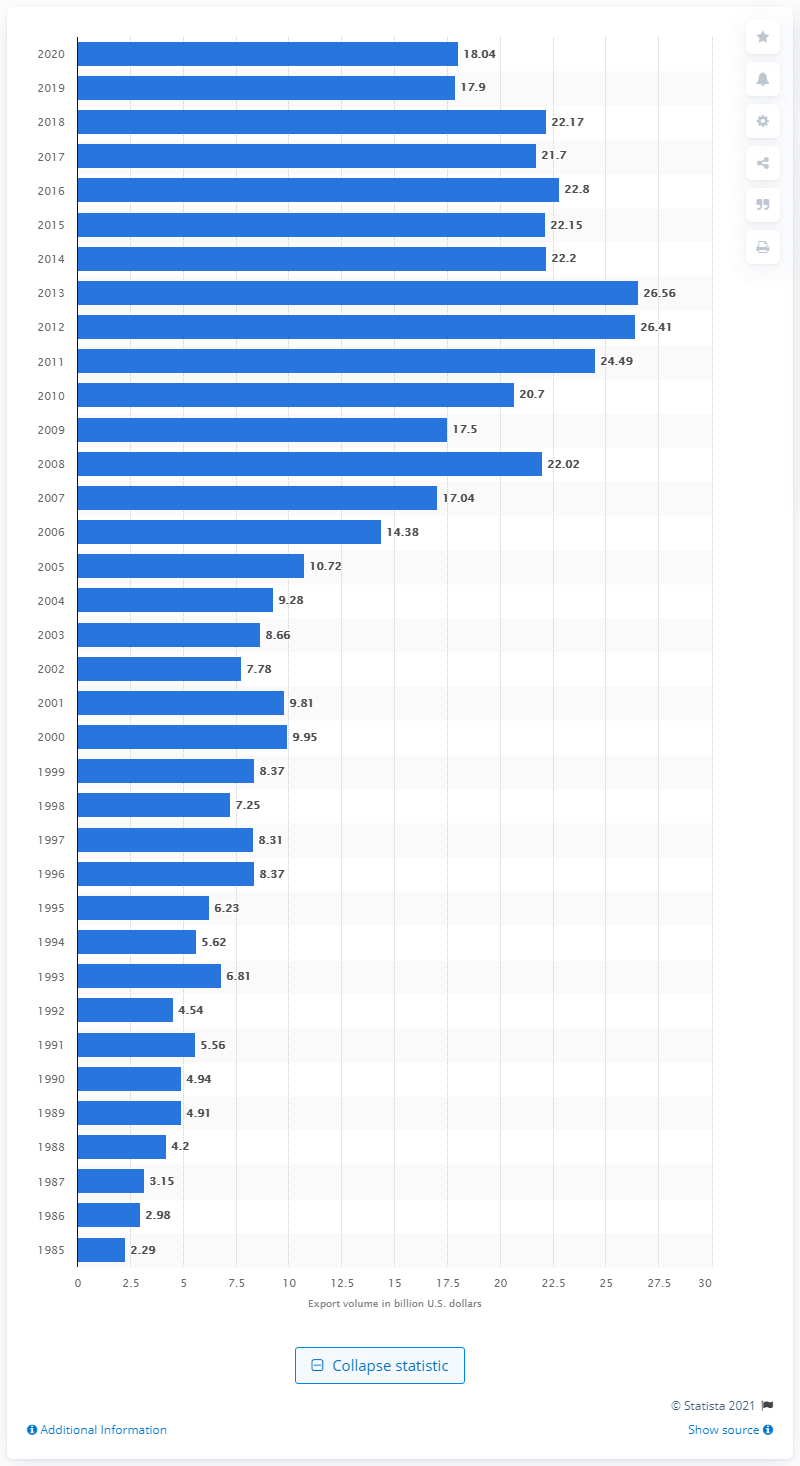Mention a couple of crucial points in this snapshot. In 2020, the United States exported 18.04 billion dollars to Switzerland. 